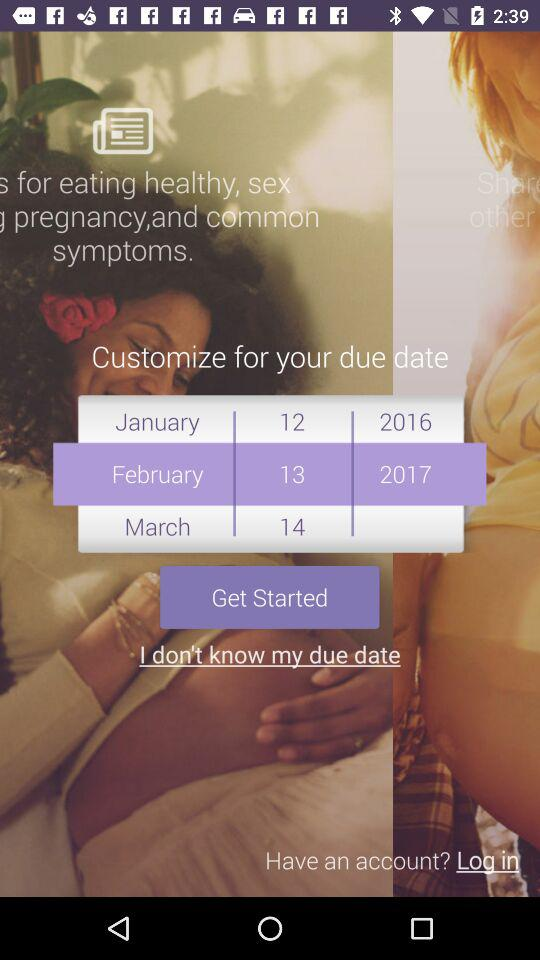Which is the customized due date? The customized due date is February 13, 2017. 